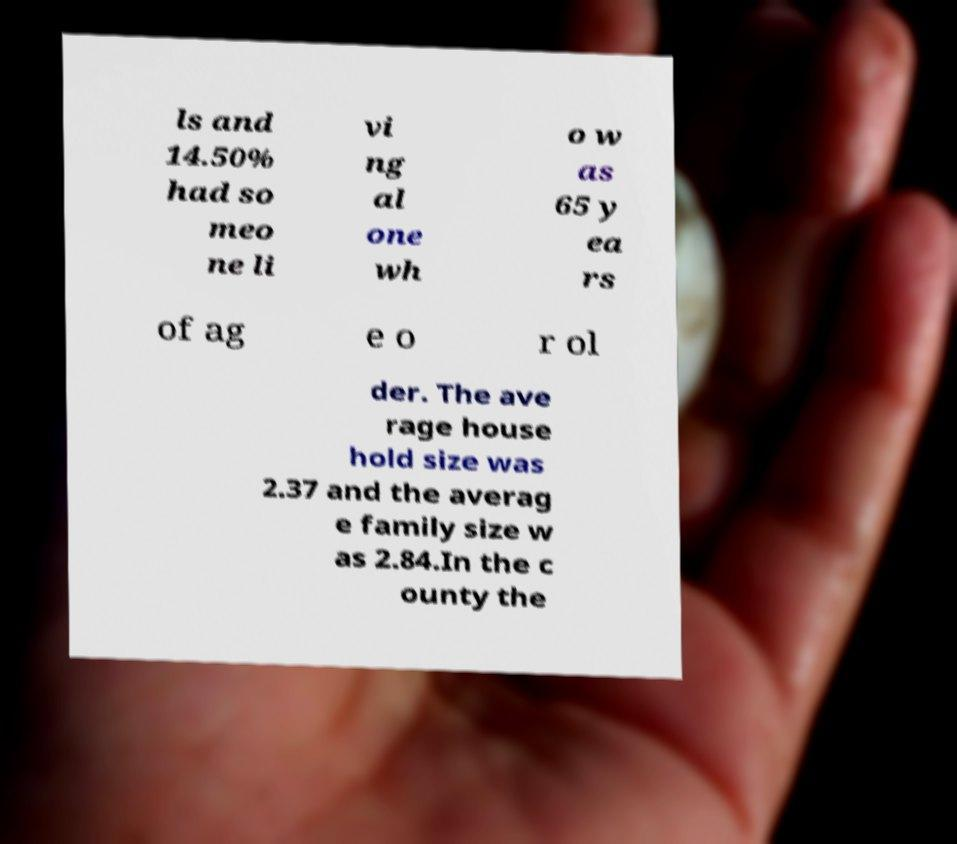For documentation purposes, I need the text within this image transcribed. Could you provide that? ls and 14.50% had so meo ne li vi ng al one wh o w as 65 y ea rs of ag e o r ol der. The ave rage house hold size was 2.37 and the averag e family size w as 2.84.In the c ounty the 